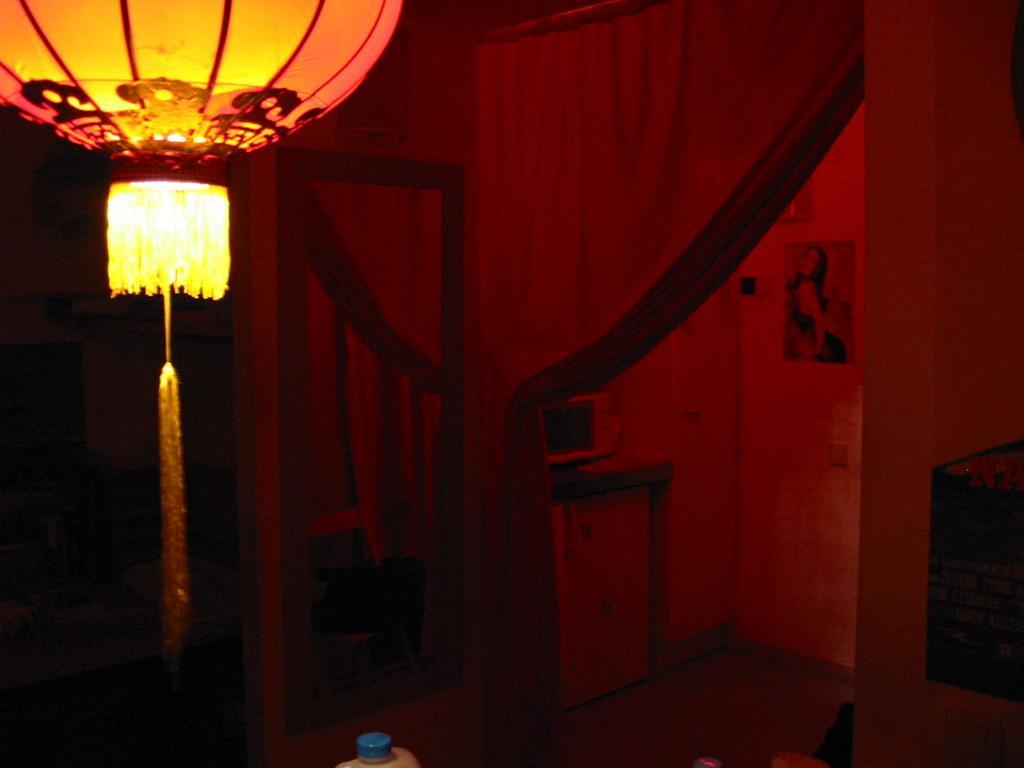Could you give a brief overview of what you see in this image? This picture is clicked inside the room. At the bottom, we see a white can with a blue color lid. On the right side, we see a black object and a wall. In the middle, we see a mirror. Beside that, we see the curtain and a table on which an object is placed. Beside that, we see a cupboard. In the background, we see a wall on which a photo frame is placed. On the left side it is black in color and we see a wall. In the left top, we see the chandelier. 